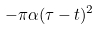Convert formula to latex. <formula><loc_0><loc_0><loc_500><loc_500>- \pi \alpha ( \tau - t ) ^ { 2 }</formula> 